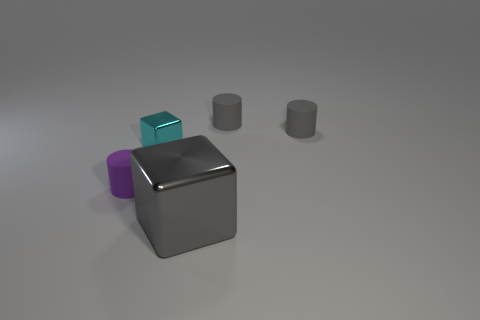Is there any other thing that has the same size as the gray shiny block?
Your answer should be compact. No. Are there more gray cubes to the right of the tiny block than tiny yellow rubber spheres?
Your response must be concise. Yes. How many big gray shiny things are on the right side of the thing in front of the purple thing?
Offer a very short reply. 0. What shape is the metal thing on the left side of the cube that is in front of the rubber object on the left side of the large gray metallic cube?
Ensure brevity in your answer.  Cube. The cyan cube is what size?
Your response must be concise. Small. Is there another cube made of the same material as the small block?
Your answer should be compact. Yes. What size is the other metallic object that is the same shape as the large gray metal thing?
Your response must be concise. Small. Is the number of tiny metal things that are behind the cyan thing the same as the number of gray cylinders?
Offer a terse response. No. There is a shiny object that is on the left side of the big block; does it have the same shape as the gray shiny object?
Your response must be concise. Yes. The tiny cyan object is what shape?
Your response must be concise. Cube. 